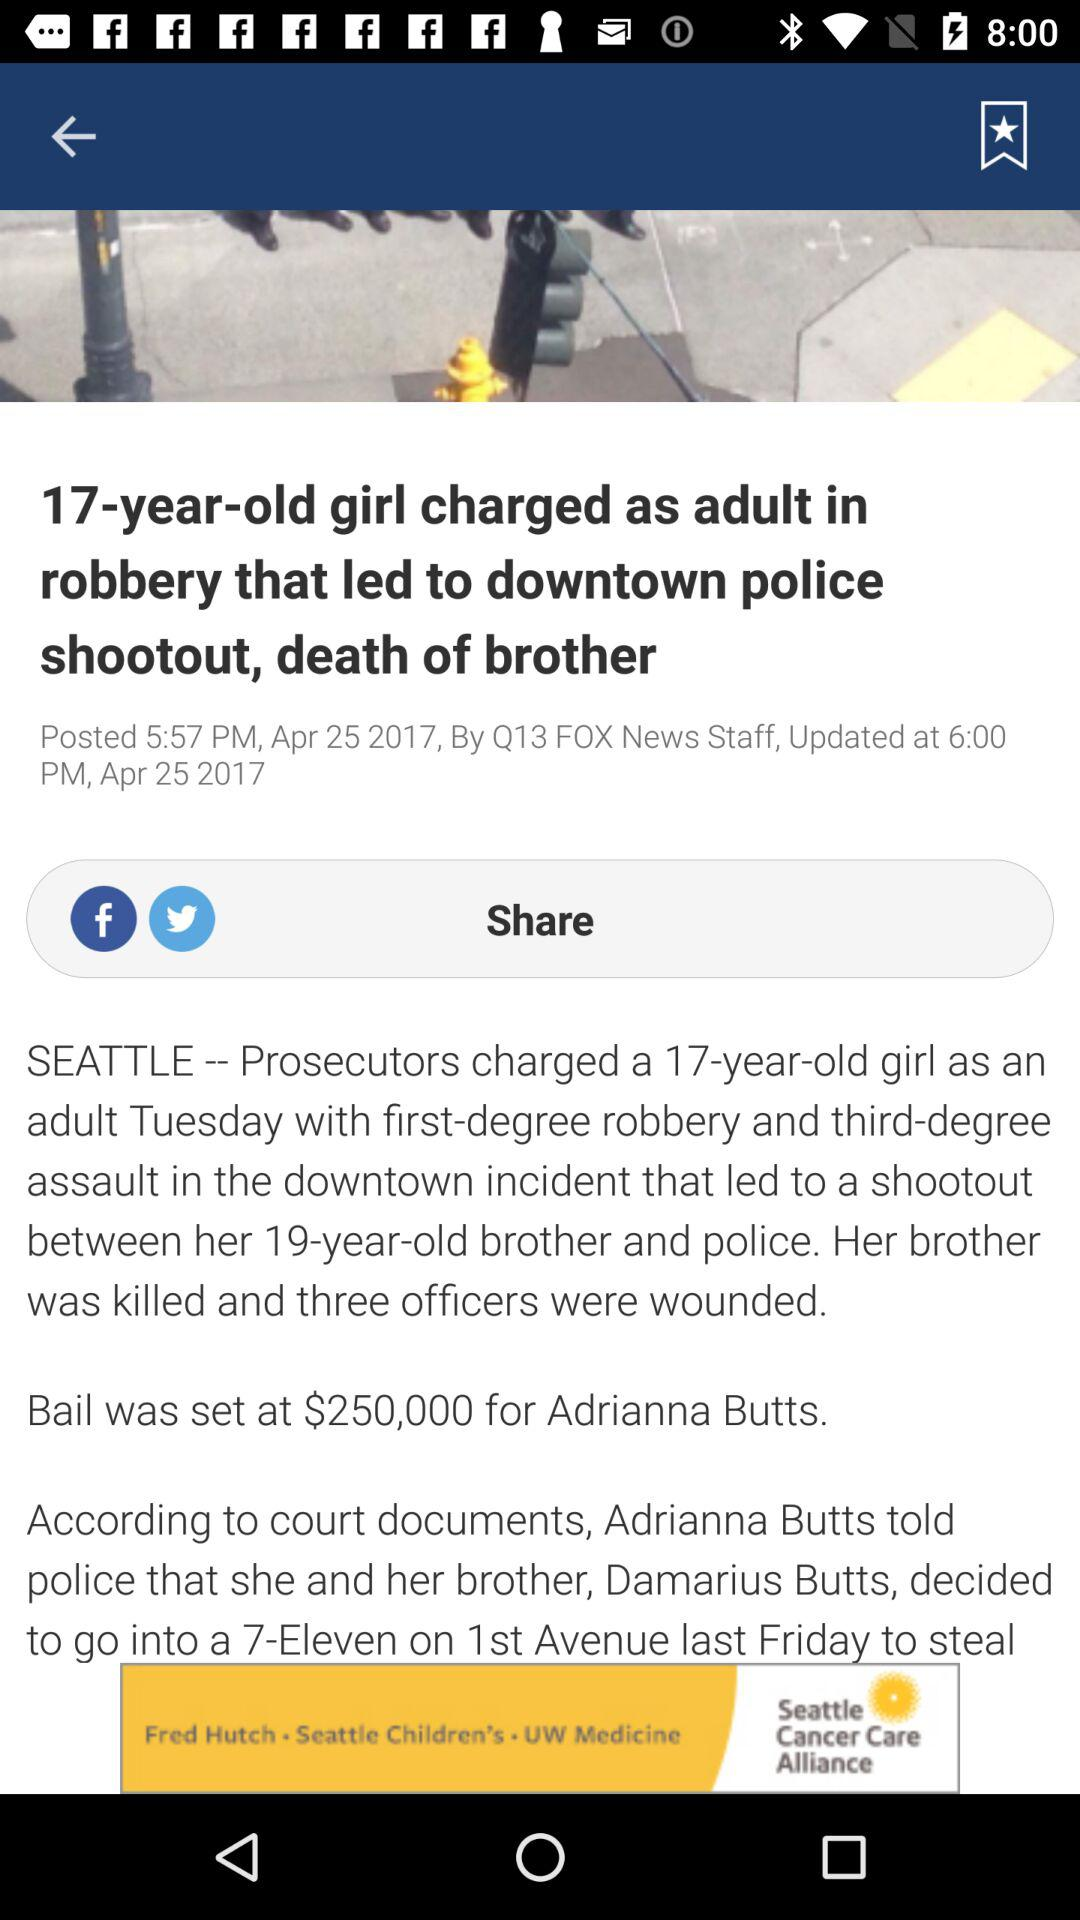Who posted the news? The news was posted by "Q13 FOX News Staff". 